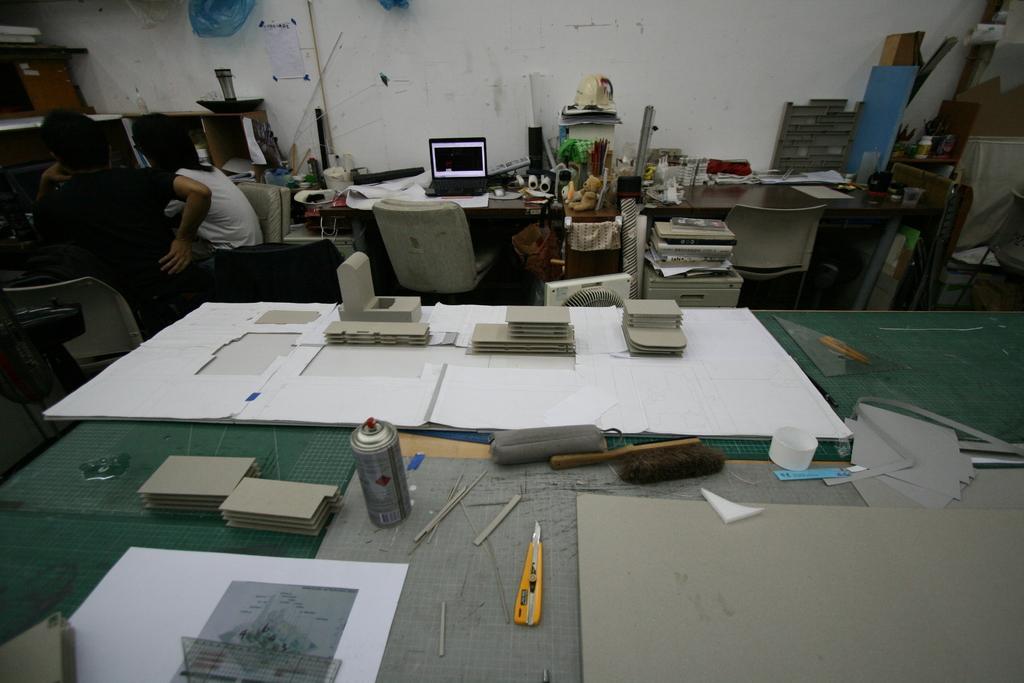How would you summarize this image in a sentence or two? This picture is of inside the room. In the foreground there is a table on the top of which paper sheets, cardboard, brush, bottle and some other geometrical instruments are placed, behind that there is another table on the top of which laptop and many other items are placed and there are two chairs, books. On the left corner there are two persons sitting on the chairs. In the background we can see a wall and some other items in the right corner. 